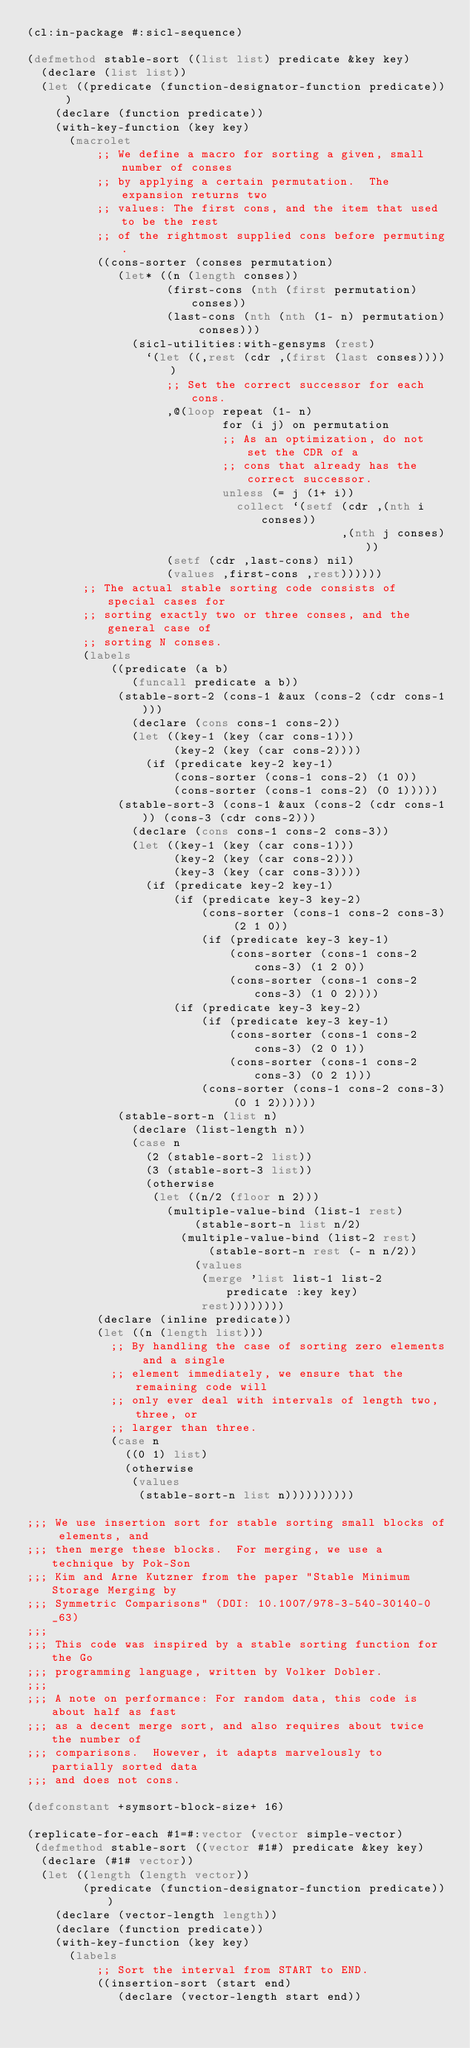<code> <loc_0><loc_0><loc_500><loc_500><_Lisp_>(cl:in-package #:sicl-sequence)

(defmethod stable-sort ((list list) predicate &key key)
  (declare (list list))
  (let ((predicate (function-designator-function predicate)))
    (declare (function predicate))
    (with-key-function (key key)
      (macrolet
          ;; We define a macro for sorting a given, small number of conses
          ;; by applying a certain permutation.  The expansion returns two
          ;; values: The first cons, and the item that used to be the rest
          ;; of the rightmost supplied cons before permuting.
          ((cons-sorter (conses permutation)
             (let* ((n (length conses))
                    (first-cons (nth (first permutation) conses))
                    (last-cons (nth (nth (1- n) permutation) conses)))
               (sicl-utilities:with-gensyms (rest)
                 `(let ((,rest (cdr ,(first (last conses)))))
                    ;; Set the correct successor for each cons.
                    ,@(loop repeat (1- n)
                            for (i j) on permutation
                            ;; As an optimization, do not set the CDR of a
                            ;; cons that already has the correct successor.
                            unless (= j (1+ i))
                              collect `(setf (cdr ,(nth i conses))
                                             ,(nth j conses)))
                    (setf (cdr ,last-cons) nil)
                    (values ,first-cons ,rest))))))
        ;; The actual stable sorting code consists of special cases for
        ;; sorting exactly two or three conses, and the general case of
        ;; sorting N conses.
        (labels
            ((predicate (a b)
               (funcall predicate a b))
             (stable-sort-2 (cons-1 &aux (cons-2 (cdr cons-1)))
               (declare (cons cons-1 cons-2))
               (let ((key-1 (key (car cons-1)))
                     (key-2 (key (car cons-2))))
                 (if (predicate key-2 key-1)
                     (cons-sorter (cons-1 cons-2) (1 0))
                     (cons-sorter (cons-1 cons-2) (0 1)))))
             (stable-sort-3 (cons-1 &aux (cons-2 (cdr cons-1)) (cons-3 (cdr cons-2)))
               (declare (cons cons-1 cons-2 cons-3))
               (let ((key-1 (key (car cons-1)))
                     (key-2 (key (car cons-2)))
                     (key-3 (key (car cons-3))))
                 (if (predicate key-2 key-1)
                     (if (predicate key-3 key-2)
                         (cons-sorter (cons-1 cons-2 cons-3) (2 1 0))
                         (if (predicate key-3 key-1)
                             (cons-sorter (cons-1 cons-2 cons-3) (1 2 0))
                             (cons-sorter (cons-1 cons-2 cons-3) (1 0 2))))
                     (if (predicate key-3 key-2)
                         (if (predicate key-3 key-1)
                             (cons-sorter (cons-1 cons-2 cons-3) (2 0 1))
                             (cons-sorter (cons-1 cons-2 cons-3) (0 2 1)))
                         (cons-sorter (cons-1 cons-2 cons-3) (0 1 2))))))
             (stable-sort-n (list n)
               (declare (list-length n))
               (case n
                 (2 (stable-sort-2 list))
                 (3 (stable-sort-3 list))
                 (otherwise
                  (let ((n/2 (floor n 2)))
                    (multiple-value-bind (list-1 rest)
                        (stable-sort-n list n/2)
                      (multiple-value-bind (list-2 rest)
                          (stable-sort-n rest (- n n/2))
                        (values
                         (merge 'list list-1 list-2 predicate :key key)
                         rest))))))))
          (declare (inline predicate))
          (let ((n (length list)))
            ;; By handling the case of sorting zero elements and a single
            ;; element immediately, we ensure that the remaining code will
            ;; only ever deal with intervals of length two, three, or
            ;; larger than three.
            (case n
              ((0 1) list)
              (otherwise
               (values
                (stable-sort-n list n))))))))))

;;; We use insertion sort for stable sorting small blocks of elements, and
;;; then merge these blocks.  For merging, we use a technique by Pok-Son
;;; Kim and Arne Kutzner from the paper "Stable Minimum Storage Merging by
;;; Symmetric Comparisons" (DOI: 10.1007/978-3-540-30140-0_63)
;;;
;;; This code was inspired by a stable sorting function for the Go
;;; programming language, written by Volker Dobler.
;;;
;;; A note on performance: For random data, this code is about half as fast
;;; as a decent merge sort, and also requires about twice the number of
;;; comparisons.  However, it adapts marvelously to partially sorted data
;;; and does not cons.

(defconstant +symsort-block-size+ 16)

(replicate-for-each #1=#:vector (vector simple-vector)
 (defmethod stable-sort ((vector #1#) predicate &key key)
  (declare (#1# vector))
  (let ((length (length vector))
        (predicate (function-designator-function predicate)))
    (declare (vector-length length))
    (declare (function predicate))
    (with-key-function (key key)
      (labels
          ;; Sort the interval from START to END.
          ((insertion-sort (start end)
             (declare (vector-length start end))</code> 